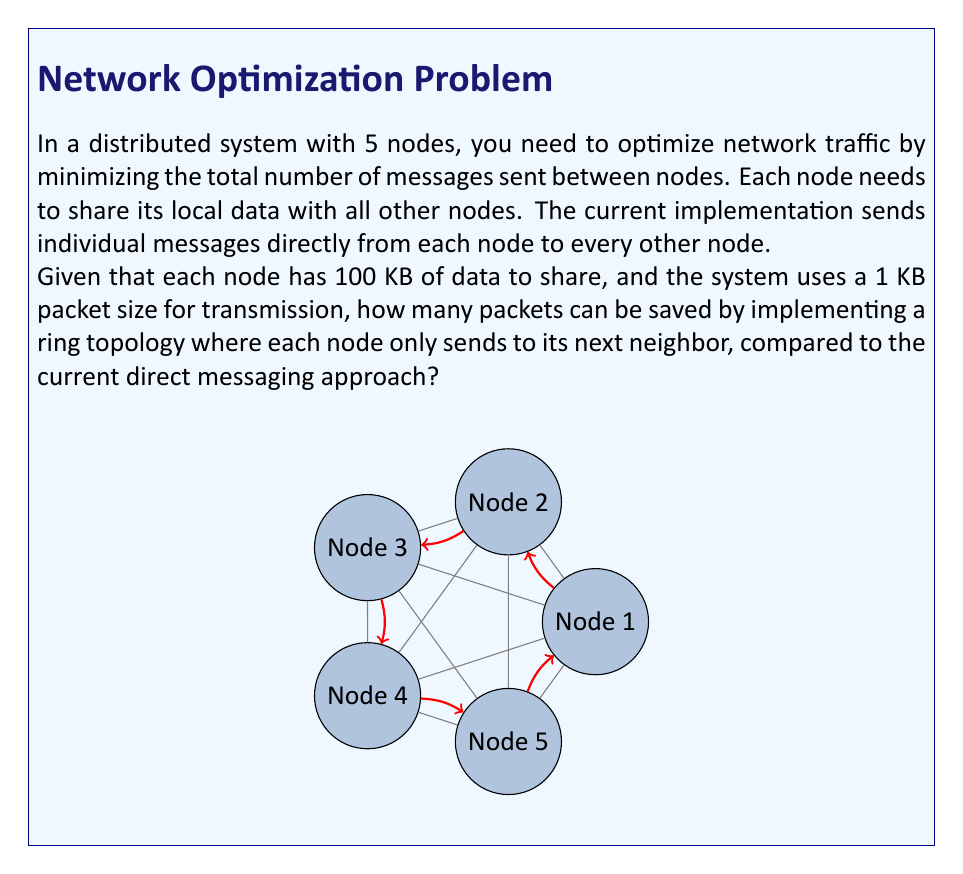What is the answer to this math problem? Let's approach this step-by-step:

1) First, calculate the number of packets in the current direct messaging approach:
   - Each node sends to 4 other nodes
   - Each message is 100 KB, which requires $\frac{100 \text{ KB}}{1 \text{ KB/packet}} = 100$ packets
   - Total packets = $5 \text{ nodes} \times 4 \text{ destinations} \times 100 \text{ packets} = 2000$ packets

2) Now, calculate the number of packets in the ring topology:
   - Each node sends to only 1 other node (its next neighbor)
   - The data circulates through all nodes
   - Total packets = $5 \text{ nodes} \times 1 \text{ destination} \times 100 \text{ packets} = 500$ packets

3) Calculate the difference:
   $\text{Packets saved} = 2000 - 500 = 1500$ packets

Therefore, implementing a ring topology saves 1500 packets compared to the direct messaging approach.
Answer: 1500 packets 